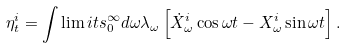Convert formula to latex. <formula><loc_0><loc_0><loc_500><loc_500>\eta ^ { i } _ { t } = \int \lim i t s _ { 0 } ^ { \infty } d \omega \lambda _ { \omega } \left [ \dot { X } ^ { i } _ { \omega } \cos \omega t - X ^ { i } _ { \omega } \sin \omega t \right ] .</formula> 